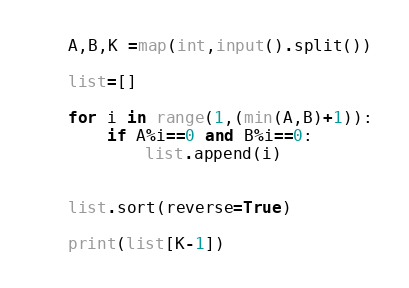<code> <loc_0><loc_0><loc_500><loc_500><_Python_>A,B,K =map(int,input().split())

list=[]

for i in range(1,(min(A,B)+1)):
    if A%i==0 and B%i==0:
        list.append(i)
    

list.sort(reverse=True)

print(list[K-1])</code> 